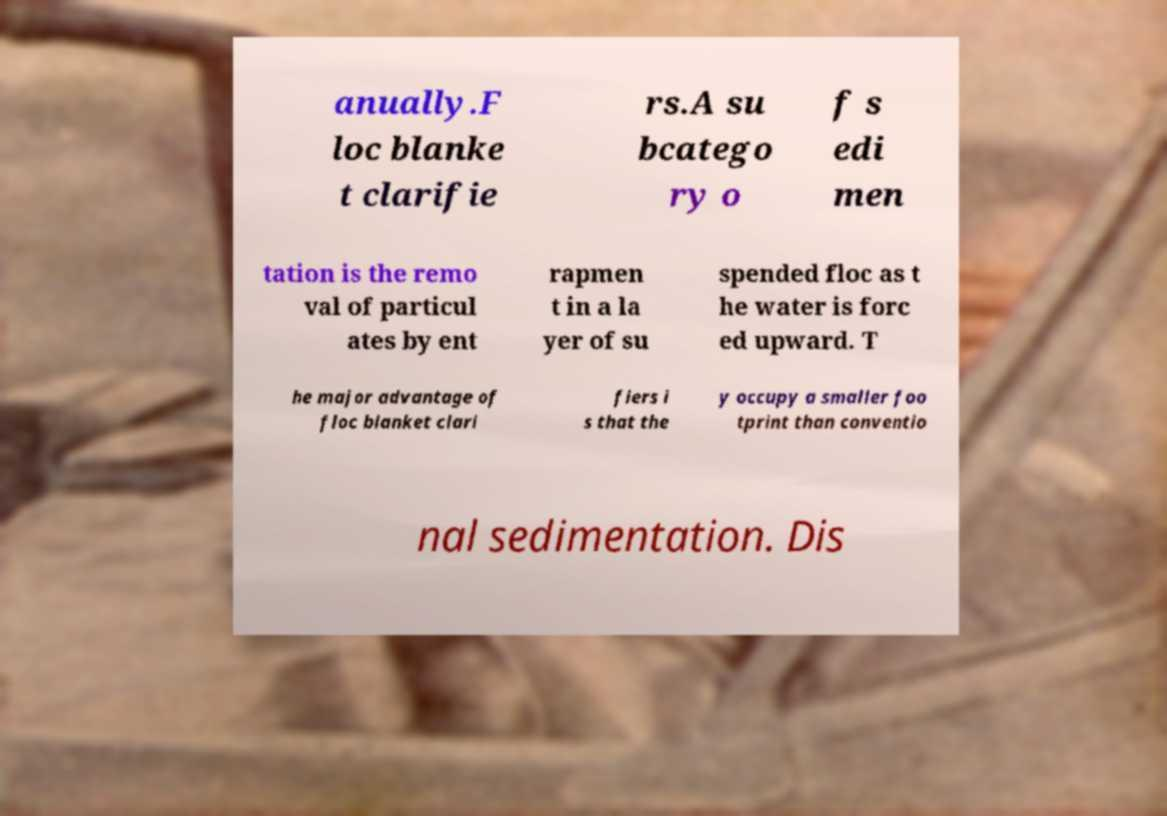Could you extract and type out the text from this image? anually.F loc blanke t clarifie rs.A su bcatego ry o f s edi men tation is the remo val of particul ates by ent rapmen t in a la yer of su spended floc as t he water is forc ed upward. T he major advantage of floc blanket clari fiers i s that the y occupy a smaller foo tprint than conventio nal sedimentation. Dis 